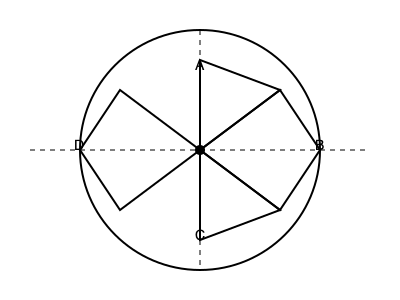Based on the historical significance of Talysh tribal symbols, which arrangement of the symbols A, B, C, and D correctly represents their importance in Talysh Khanate society from most to least significant? To answer this question, we need to consider the historical significance of Talysh tribal symbols and their arrangement in the given diagram. Here's a step-by-step explanation:

1. The Talysh Khanate was a feudal state that existed in the 18th and 19th centuries in what is now southern Azerbaijan and northern Iran.

2. In Talysh society, tribal symbols were often arranged in a hierarchical order reflecting their importance.

3. The circular arrangement in the diagram suggests a cyclical or interconnected relationship between the symbols.

4. The central position (where all lines intersect) is typically reserved for the most significant symbol in many cultures, including the Talysh.

5. In this diagram, symbol A is placed at the top, which often indicates high status or importance in hierarchical representations.

6. Symbol B is positioned to the right, which in many Middle Eastern cultures (including the Talysh) is considered a position of honor.

7. Symbol C is at the bottom, which usually represents a foundational but less prominent position.

8. Symbol D is on the left, typically considered less significant than the right in the cultural context of the region.

9. The diamond shapes connecting the symbols suggest interconnectedness, with the largest diamond connecting B and C, indicating a strong relationship between these two.

10. Based on this analysis, the most likely arrangement from most to least significant would be: A (top position), B (right position), C (bottom position), and D (left position).

Therefore, the correct arrangement of the symbols from most to least significant in Talysh Khanate society would be A, B, C, D.
Answer: A, B, C, D 